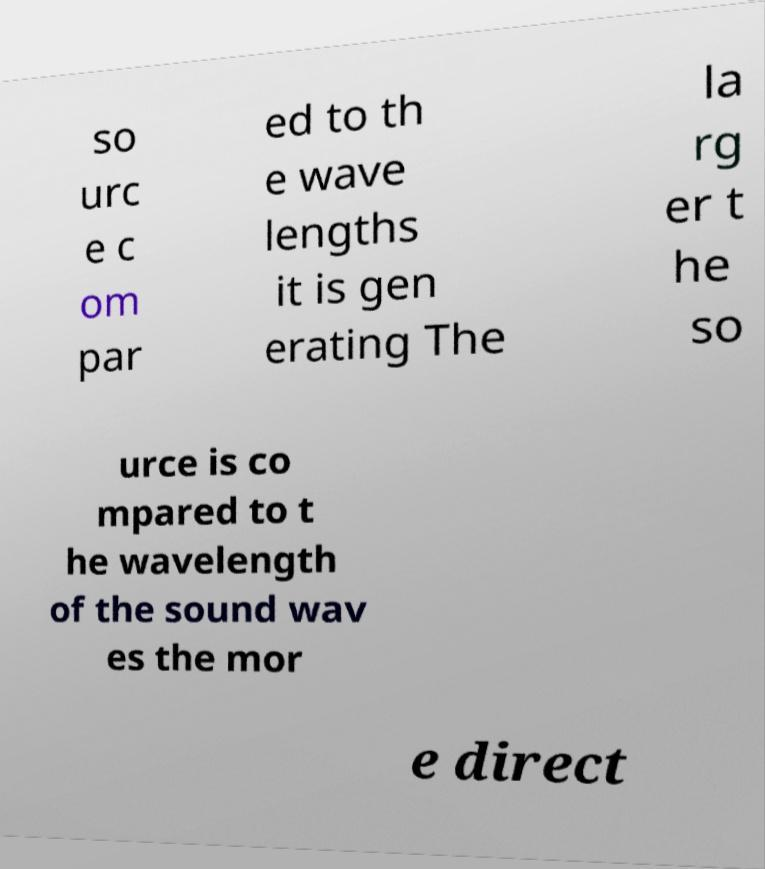Can you accurately transcribe the text from the provided image for me? so urc e c om par ed to th e wave lengths it is gen erating The la rg er t he so urce is co mpared to t he wavelength of the sound wav es the mor e direct 